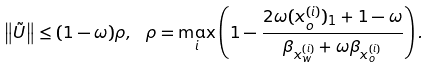<formula> <loc_0><loc_0><loc_500><loc_500>\left \| \tilde { U } \right \| \leq ( 1 - \omega ) \rho , \ \rho = \max _ { i } \left ( 1 - \frac { 2 \omega ( x _ { o } ^ { ( i ) } ) _ { 1 } + 1 - \omega } { \beta _ { x _ { w } ^ { ( i ) } } + \omega \beta _ { x _ { o } ^ { ( i ) } } } \right ) .</formula> 